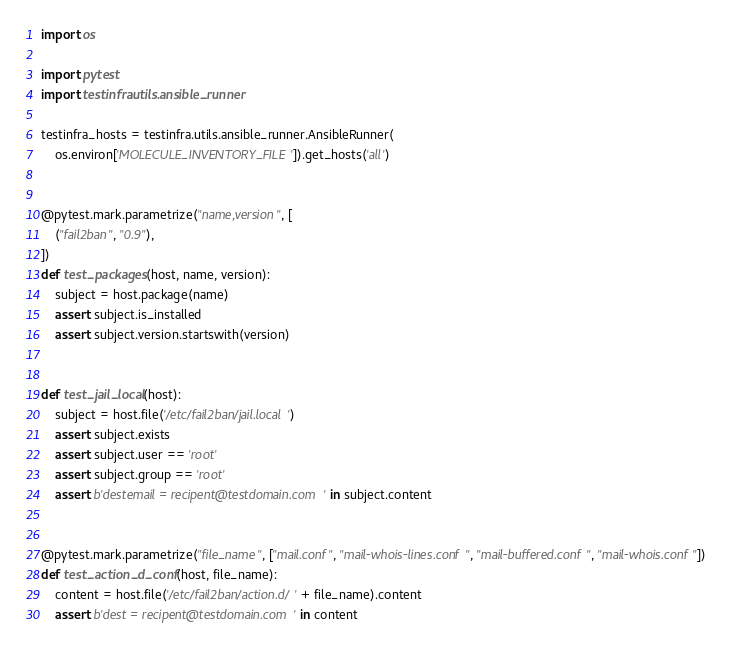<code> <loc_0><loc_0><loc_500><loc_500><_Python_>import os

import pytest
import testinfra.utils.ansible_runner

testinfra_hosts = testinfra.utils.ansible_runner.AnsibleRunner(
    os.environ['MOLECULE_INVENTORY_FILE']).get_hosts('all')


@pytest.mark.parametrize("name,version", [
    ("fail2ban", "0.9"),
])
def test_packages(host, name, version):
    subject = host.package(name)
    assert subject.is_installed
    assert subject.version.startswith(version)


def test_jail_local(host):
    subject = host.file('/etc/fail2ban/jail.local')
    assert subject.exists
    assert subject.user == 'root'
    assert subject.group == 'root'
    assert b'destemail = recipent@testdomain.com' in subject.content


@pytest.mark.parametrize("file_name", ["mail.conf", "mail-whois-lines.conf", "mail-buffered.conf", "mail-whois.conf"])
def test_action_d_conf(host, file_name):
    content = host.file('/etc/fail2ban/action.d/' + file_name).content
    assert b'dest = recipent@testdomain.com' in content
</code> 